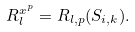Convert formula to latex. <formula><loc_0><loc_0><loc_500><loc_500>R ^ { x ^ { p } } _ { l } = R _ { l , p } ( S _ { i , k } ) .</formula> 